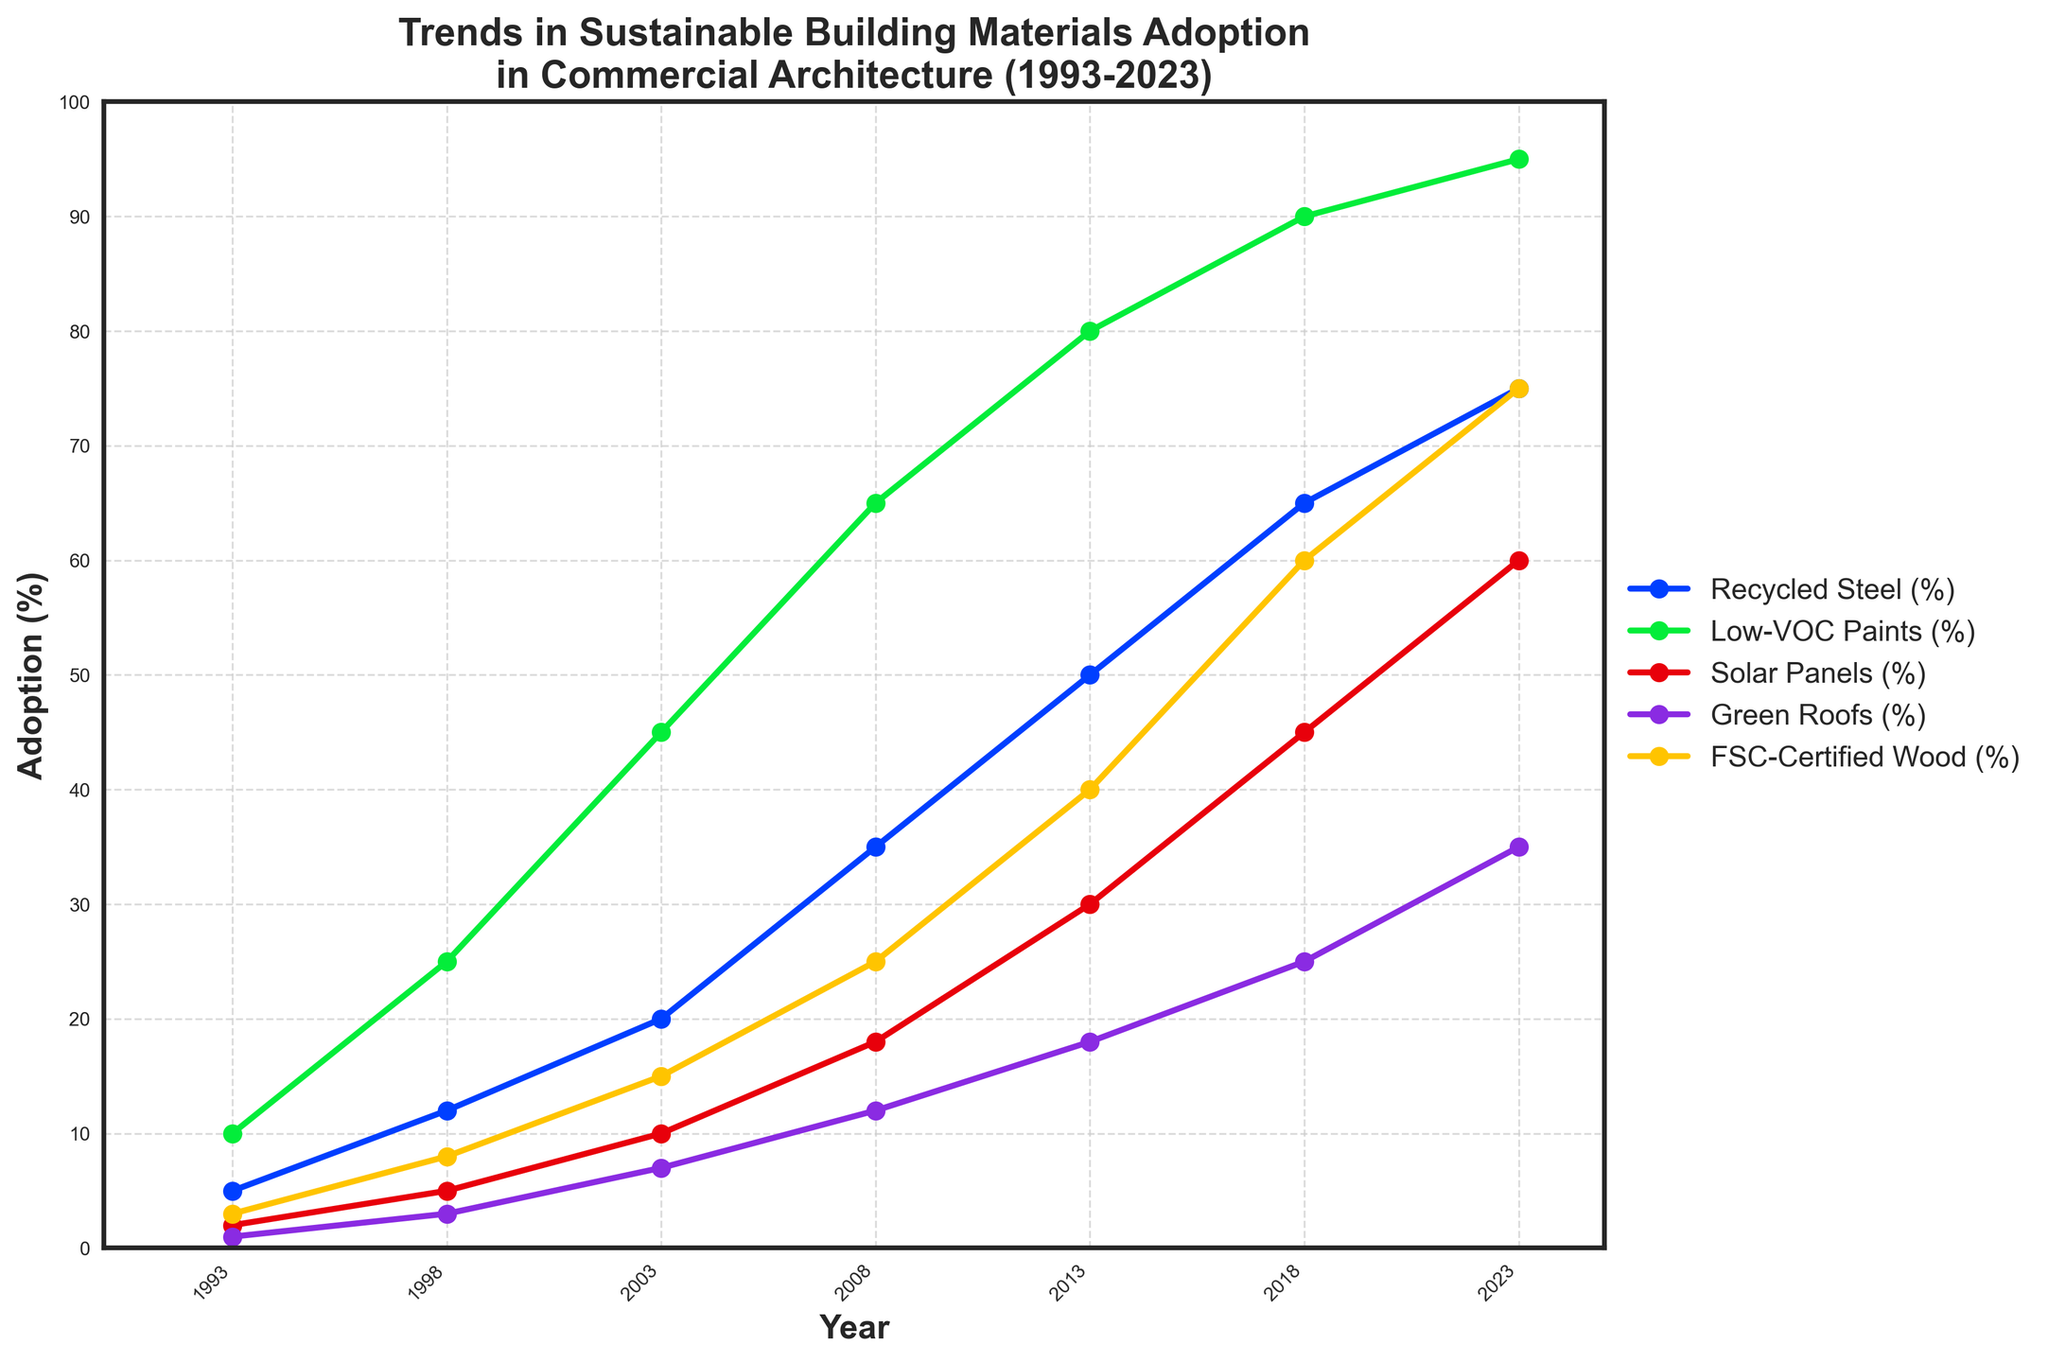What material had the highest adoption percentage in 2023? From the chart, identify and compare the final points of each line representing different materials. The highest point in 2023 corresponds to Low-VOC Paints with 95%.
Answer: Low-VOC Paints How much did the adoption of Solar Panels increase from 1993 to 2023? Locate the values for Solar Panels in 1993 and 2023. Subtract the 1993 value from the 2023 value: 60% - 2% = 58%.
Answer: 58% Which material showed the most significant change in adoption between 2003 and 2008? Compare the values for each material in 2003 and 2008 to find the difference. Calculate these differences and find the largest one: Recycled Steel (35-20=15), Low-VOC Paints (65-45=20), Solar Panels (18-10=8), Green Roofs (12-7=5), FSC-Certified Wood (25-15=10). The most significant change is in Low-VOC Paints with 20%.
Answer: Low-VOC Paints By what year did the adoption of Green Roofs reach at least 25%? Track the values for Green Roofs across the years and find the first year where the value is at least 25%. In this case, the adoption reaches 25% in 2018.
Answer: 2018 What is the adoption difference between Recycled Steel and FSC-Certified Wood in 2023? Identify the values for these two materials in 2023: Recycled Steel at 75% and FSC-Certified Wood at 75%. Subtract the smaller value from the larger one: 75% - 75% = 0%.
Answer: 0% Which two materials had the closest adoption percentages in 1998? Compare the adoption percentages for each pair of materials in 1998 and find the pair with the smallest difference: Recycled Steel (12%), Low-VOC Paints (25%), Solar Panels (5%), Green Roofs (3%), FSC-Certified Wood (8%). The closest pair is Green Roofs and Solar Panels with a difference of 2% (5% - 3% = 2%).
Answer: Green Roofs and Solar Panels What is the average adoption percentage of Low-VOC Paints over the period 1993 to 2023? Add the values of Low-VOC Paints for all years and divide by the number of years: (10% + 25% + 45% + 65% + 80% + 90% + 95%)/7 = 410%/7 = 58.57% (rounded to two decimal places).
Answer: 58.57% Which material saw the least increase in adoption from 1993 to 2023? Calculate the adoption increase for each material from 1993 to 2023 and identify the least: Recycled Steel (75% - 5% = 70%), Low-VOC Paints (95% - 10% = 85%), Solar Panels (60% - 2% = 58%), Green Roofs (35% - 1% = 34%), FSC-Certified Wood (75% - 3% = 72%). Green Roofs have the smallest increase with 34%.
Answer: Green Roofs What is the total percentage growth in adoption for the five materials from 1993 to 2023? Find the total adoption percentage for all materials in 1993 and 2023, then calculate the growth. 1993 total: 5% + 10% + 2% + 1% + 3% = 21%. 2023 total: 75% + 95% + 60% + 35% + 75% = 340%. Growth: 340% - 21% = 319%.
Answer: 319% In which year did the adoption of FSC-Certified Wood surpass that of Low-VOC Paints? Compare the adoption percentages of FSC-Certified Wood and Low-VOC Paints across the years. FSC-Certified Wood (60%) exceeds Low-VOC Paints (45%) in 2018.
Answer: 2018 